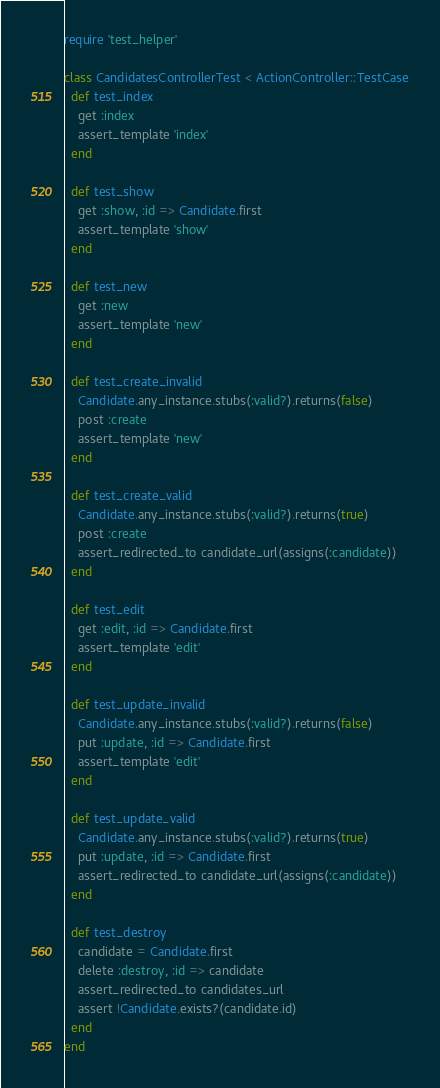<code> <loc_0><loc_0><loc_500><loc_500><_Ruby_>require 'test_helper'

class CandidatesControllerTest < ActionController::TestCase
  def test_index
    get :index
    assert_template 'index'
  end
  
  def test_show
    get :show, :id => Candidate.first
    assert_template 'show'
  end
  
  def test_new
    get :new
    assert_template 'new'
  end
  
  def test_create_invalid
    Candidate.any_instance.stubs(:valid?).returns(false)
    post :create
    assert_template 'new'
  end
  
  def test_create_valid
    Candidate.any_instance.stubs(:valid?).returns(true)
    post :create
    assert_redirected_to candidate_url(assigns(:candidate))
  end
  
  def test_edit
    get :edit, :id => Candidate.first
    assert_template 'edit'
  end
  
  def test_update_invalid
    Candidate.any_instance.stubs(:valid?).returns(false)
    put :update, :id => Candidate.first
    assert_template 'edit'
  end
  
  def test_update_valid
    Candidate.any_instance.stubs(:valid?).returns(true)
    put :update, :id => Candidate.first
    assert_redirected_to candidate_url(assigns(:candidate))
  end
  
  def test_destroy
    candidate = Candidate.first
    delete :destroy, :id => candidate
    assert_redirected_to candidates_url
    assert !Candidate.exists?(candidate.id)
  end
end
</code> 